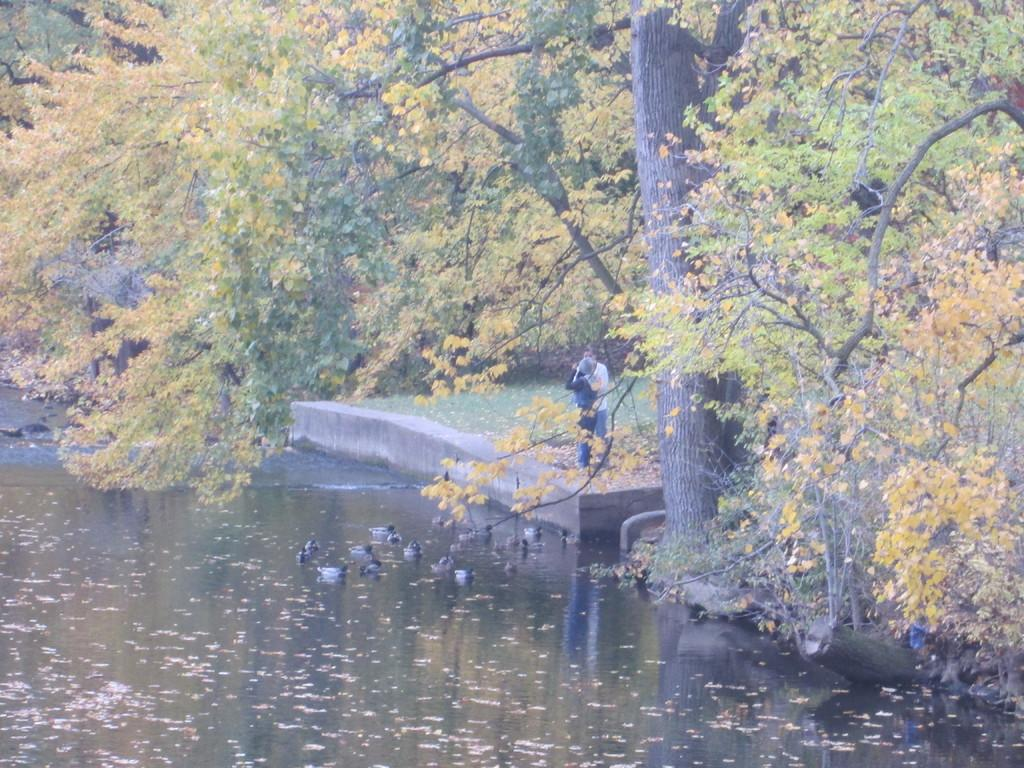What animals can be seen in the image? There are ducks on the water in the image. How many people are present in the image? There are two people standing on the ground in the image. What type of vegetation is visible in the image? Grass is visible in the image. What can be seen in the background of the image? There are trees in the background of the image. How many beds are visible in the image? There are no beds present in the image. What type of worm can be seen crawling on the ground in the image? There are no worms visible in the image. 